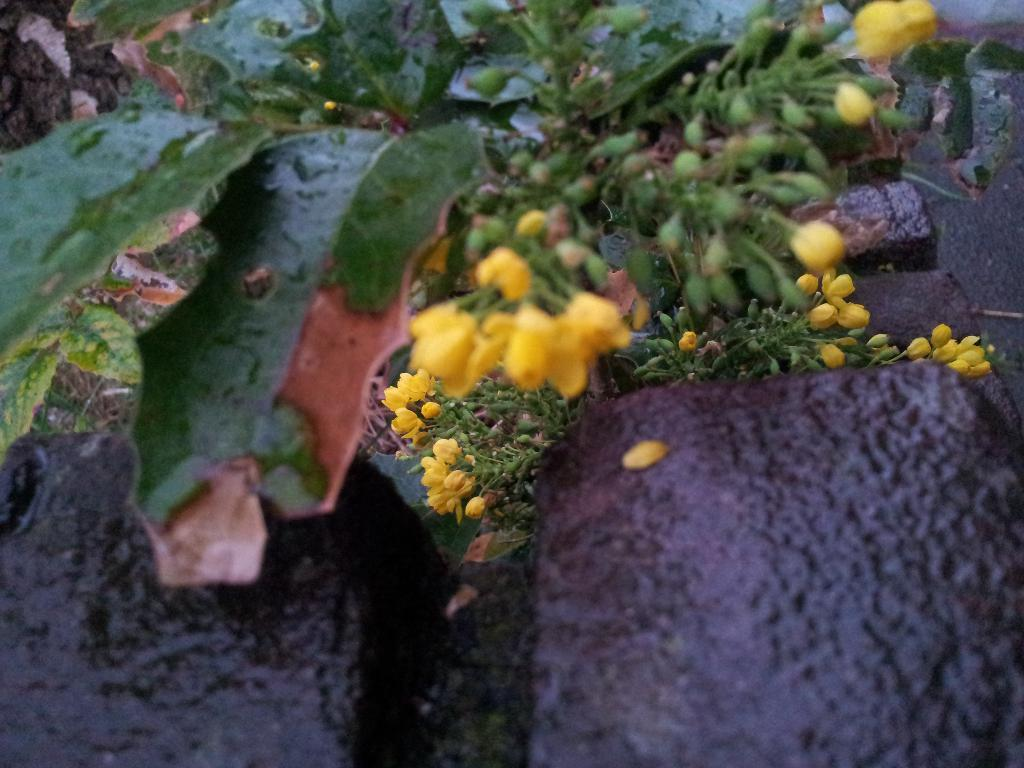What types of living organisms can be seen in the image? Plants and flowers are visible in the image. What other objects can be seen in the image besides plants and flowers? There are stones in the image. What type of pipe can be seen in the image? There is no pipe present in the image. Can you tell me how many kitties are playing with the flowers in the image? There are no kitties present in the image; it only features plants, flowers, and stones. 